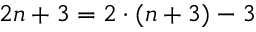<formula> <loc_0><loc_0><loc_500><loc_500>2 n + 3 = 2 \cdot ( n + 3 ) - 3</formula> 